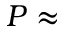<formula> <loc_0><loc_0><loc_500><loc_500>P \approx</formula> 